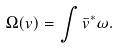Convert formula to latex. <formula><loc_0><loc_0><loc_500><loc_500>\Omega ( v ) = \int \bar { v } ^ { * } \omega .</formula> 